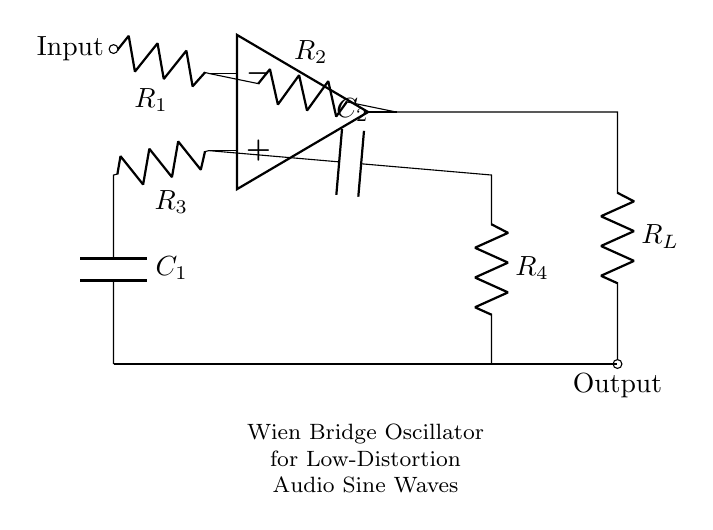What type of amplifier is used in this circuit? The circuit uses an operational amplifier, which is indicated by the symbol in the diagram. Operational amplifiers are commonly used in various configurations for signal processing.
Answer: operational amplifier What are the components connected to the inverting input? The components connected to the inverting input are R1 and R2. This can be identified by tracing the connections from the op-amp's inverting input terminal.
Answer: R1, R2 What does the capacitor C1 do in this circuit? Capacitor C1 is part of the feedback network in the oscillator configuration. It contributes to the frequency of oscillation along with the resistive elements in the circuit.
Answer: frequency modulation How do R3 and R4 affect the gain of the oscillator? R3 and R4 set the gain of the oscillator by establishing a balance in the feedback network, maintaining a condition for oscillation. Their values determine the magnitude of the output signal relative to the input.
Answer: they set the gain What output signal type does this circuit generate? The Wien bridge oscillator circuit is specifically designed to generate low-distortion sine waves, which is indicated by the circuit's configuration. This is typical in audio applications for clean signal reproduction.
Answer: sine waves What happens if R2 is removed from the circuit? Removing R2 disrupts the feedback mechanism necessary for maintaining oscillation. This would likely lead to the oscillator failing to generate an output signal or producing unstable oscillations.
Answer: oscillation failure How does this circuit obtain its oscillation frequency? The oscillation frequency is determined by the values of the resistors R3, R4, and the capacitor C1. The relationship is established through the formula for the frequency of oscillation in a Wien bridge configuration.
Answer: through R3, R4, and C1 